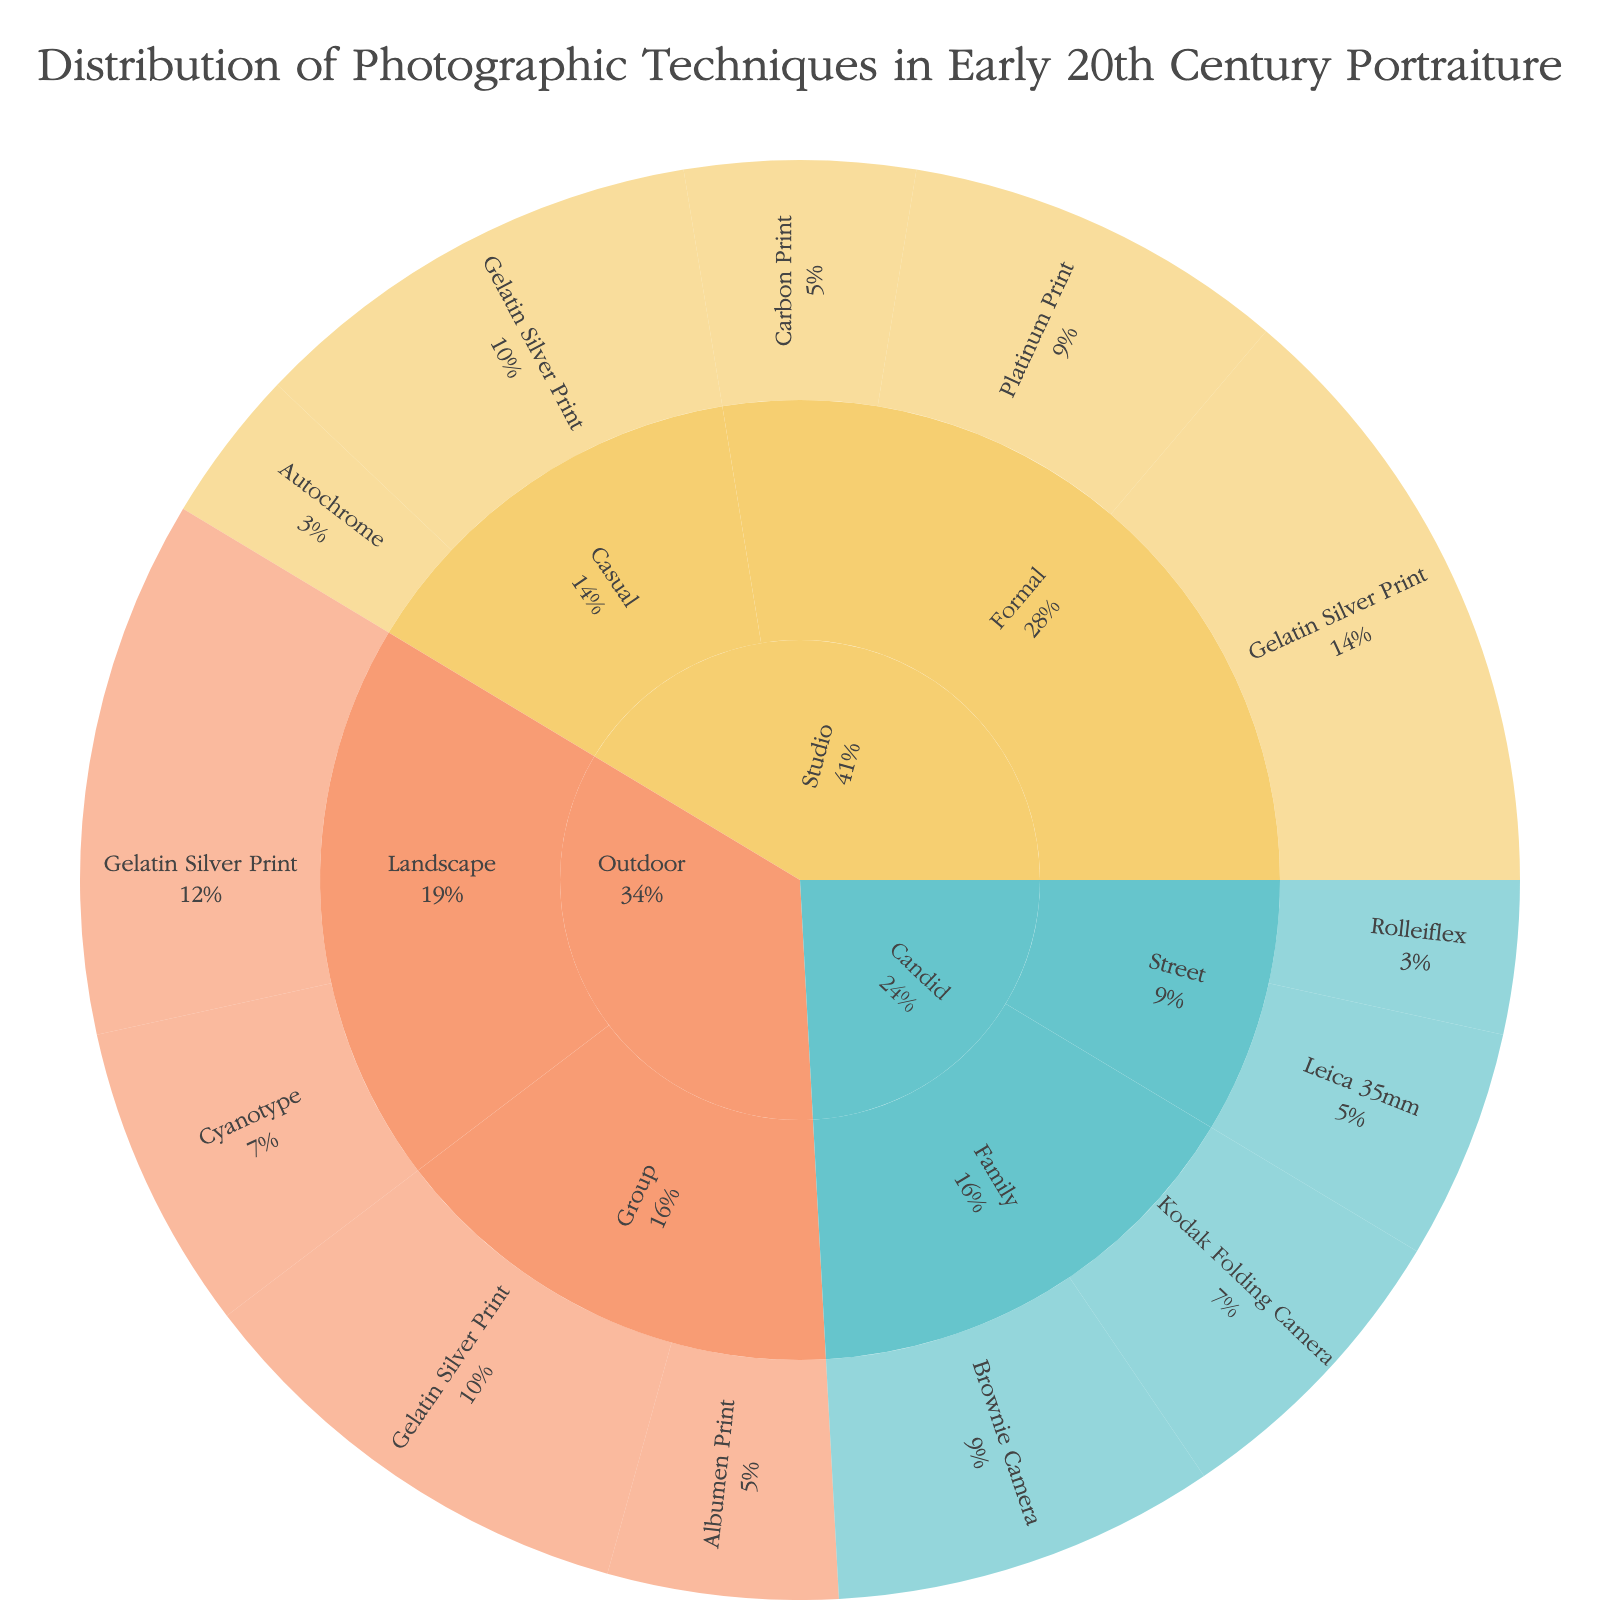What category has the highest total value of portraitures? Find the category with the sum of its subcategories; Studio is 110 (40+25+15+30+10), Outdoor is 100 (35+20+30+15), and Candid is 70 (25+20+15+10)
Answer: Studio Which subcategory under Studio has more techniques, Formal or Casual? Formal includes Gelatin Silver Print, Platinum Print, and Carbon Print (3 techniques), while Casual includes Gelatin Silver Print and Autochrome (2 techniques)
Answer: Formal What's the most utilized technique across all categories? Count all references to each technique and identify the most frequent; Gelatin Silver Print appears 6 times
Answer: Gelatin Silver Print Which category uses the least diverse range of techniques? Observe the number of unique techniques per category; Candid uses 4 techniques, while Studio and Outdoor use 5 techniques each
Answer: Candid How many photographic techniques are used under Outdoor shots? Identify and count all unique techniques under Outdoor; Gelatin Silver Print, Cyanotype, and Albumen Print
Answer: 3 Between Studio Formal and Outdoor Landscape, which has a higher collective value for Gelatin Silver Print? Studio Formal Gelatin Silver Print has a value of 40, while Outdoor Landscape Gelatin Silver Print has a value of 35
Answer: Studio Formal What is the combined value of techniques used for Candid Family shots? Combine the values for Brownie Camera and Kodak Folding Camera under Candid Family; 25 + 20
Answer: 45 Which subcategory under Outdoor has a higher value, Landscape or Group? Sum the values for each technique under the subcategories; Landscape is 55 (35+20), Group is 45 (30+15)
Answer: Landscape Under which category can Cyanotype be found? Identify the unique category where Cyanotype is listed; it’s only under Outdoor
Answer: Outdoor What is the total value of Platinum Print techniques across all subcategories? Sum the values where technique is Platinum Print; it is found only under Studio Formal with a value of 25
Answer: 25 